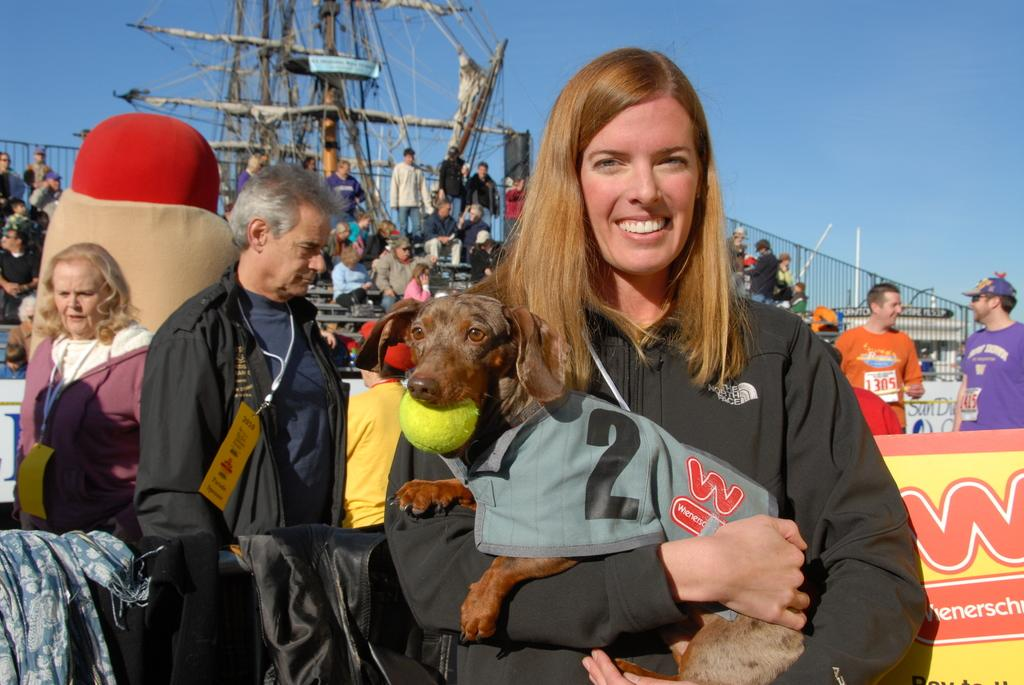What is happening in the image involving a group of people? There is a group of people in the image, but the specific activity they are engaged in is not mentioned in the facts. What is the woman holding in her hands? The woman is holding a dog in her hands. What is the dog doing in the image? The dog has a ball in its mouth. How would you describe the sky in the image? The sky is blue and cloudy. What type of chin is visible on the dog in the image? There is no chin visible on the dog in the image; it is not mentioned in the facts. What kind of lumber is being used by the people in the image? There is no mention of lumber or any construction activity in the image. 